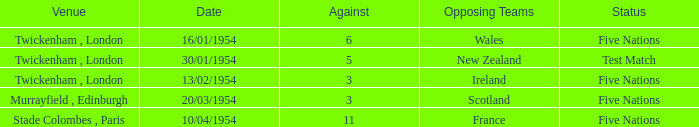What is the lowest against for games played in the stade colombes, paris venue? 11.0. 